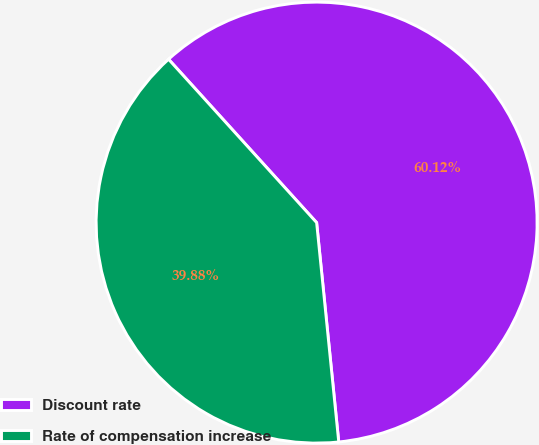<chart> <loc_0><loc_0><loc_500><loc_500><pie_chart><fcel>Discount rate<fcel>Rate of compensation increase<nl><fcel>60.12%<fcel>39.88%<nl></chart> 